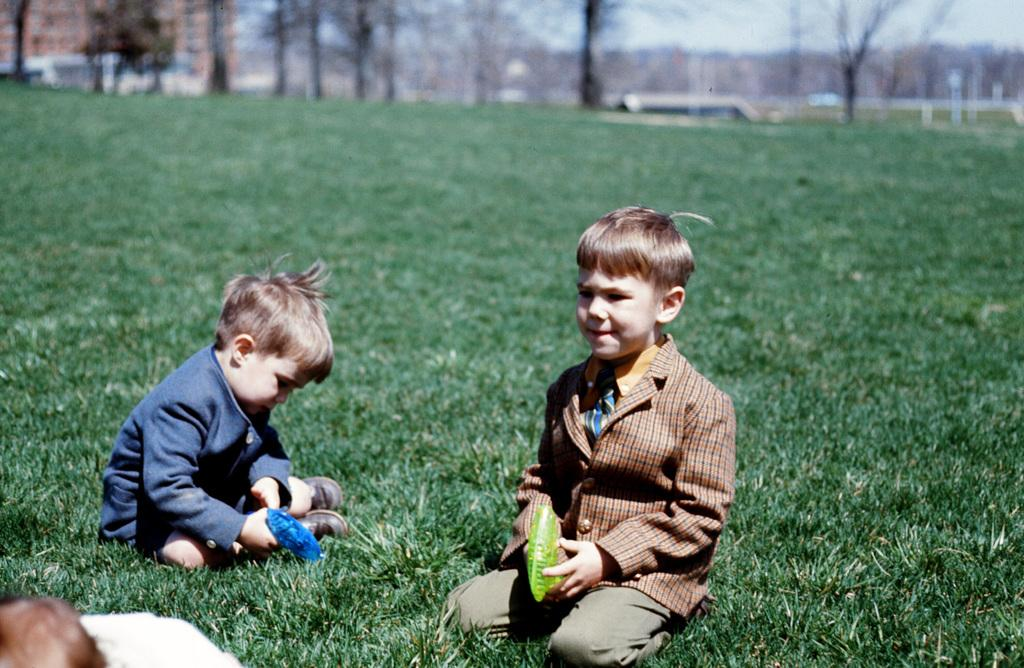What are the kids doing in the image? The kids are sitting at the bottom of the image. What are the kids holding in their hands? The kids are holding something in their hands. What type of surface can be seen beneath the kids? There is grass visible in the image. What can be seen in the distance behind the kids? There are trees in the background of the image. Reasoning: Let's think step by step by step in order to produce the conversation. We start by identifying the main subject in the image, which is the kids sitting at the bottom. Then, we expand the conversation to include what the kids are holding in their hands, as well as the surface and background details. Each question is designed to elicit a specific detail about the image that is known from the provided facts. Absurd Question/Answer: What type of vegetable is growing on the kids' wrists in the image? There is no vegetable growing on the kids' wrists in the image. What type of vegetable is growing on the kids' wrists in the image? There is no vegetable growing on the kids' wrists in the image. 